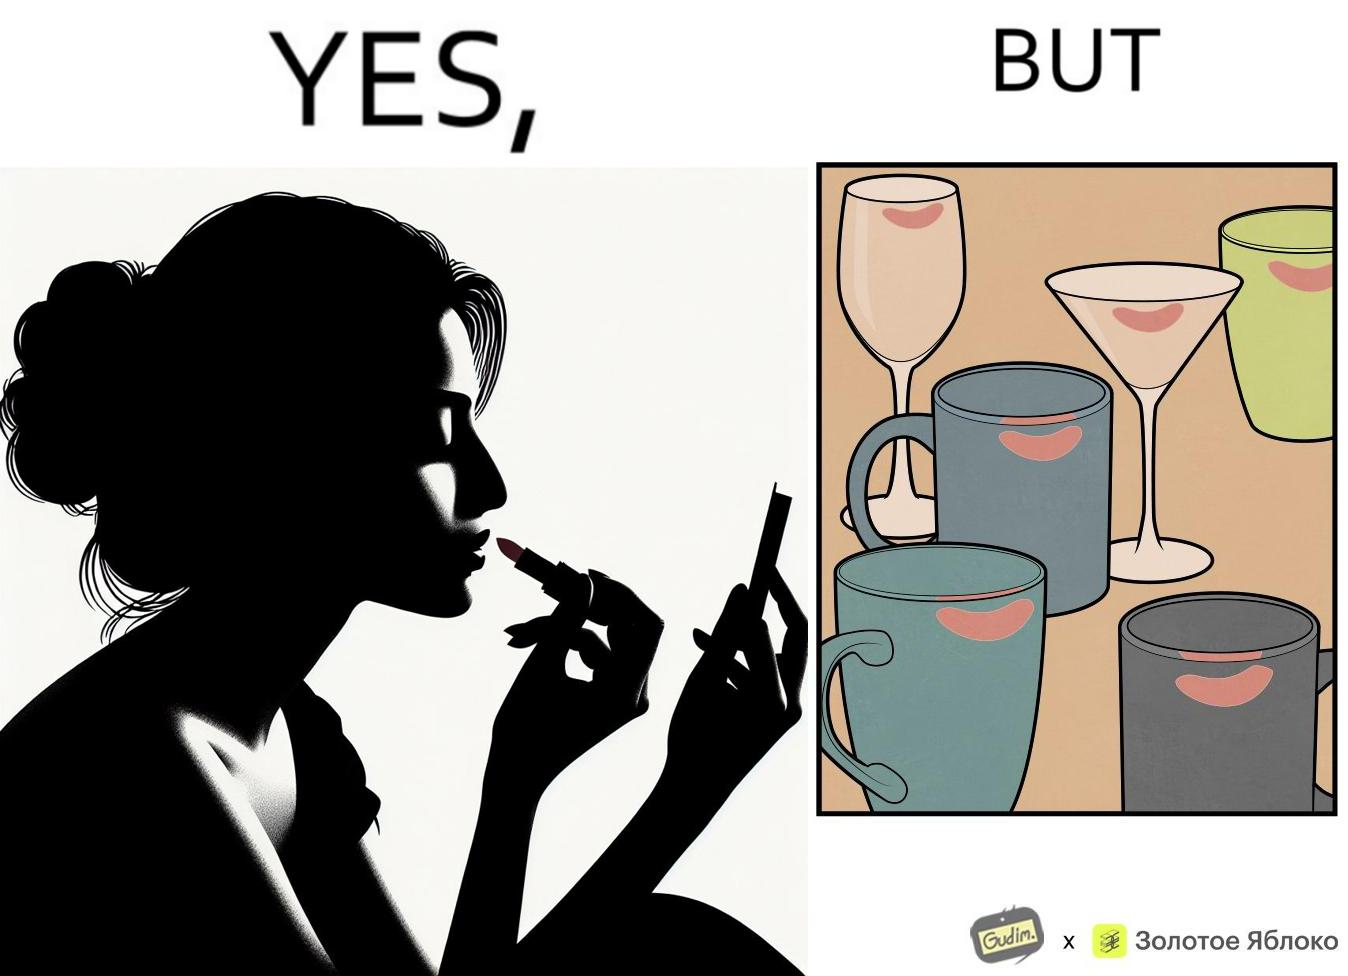What is the satirical meaning behind this image? The image is ironic, because the left image suggest that a person applies lipsticks on their lips to make their lips look attractive or to keep them hydrated but on the contrary it gets sticked to the glasses or mugs and gets wasted 